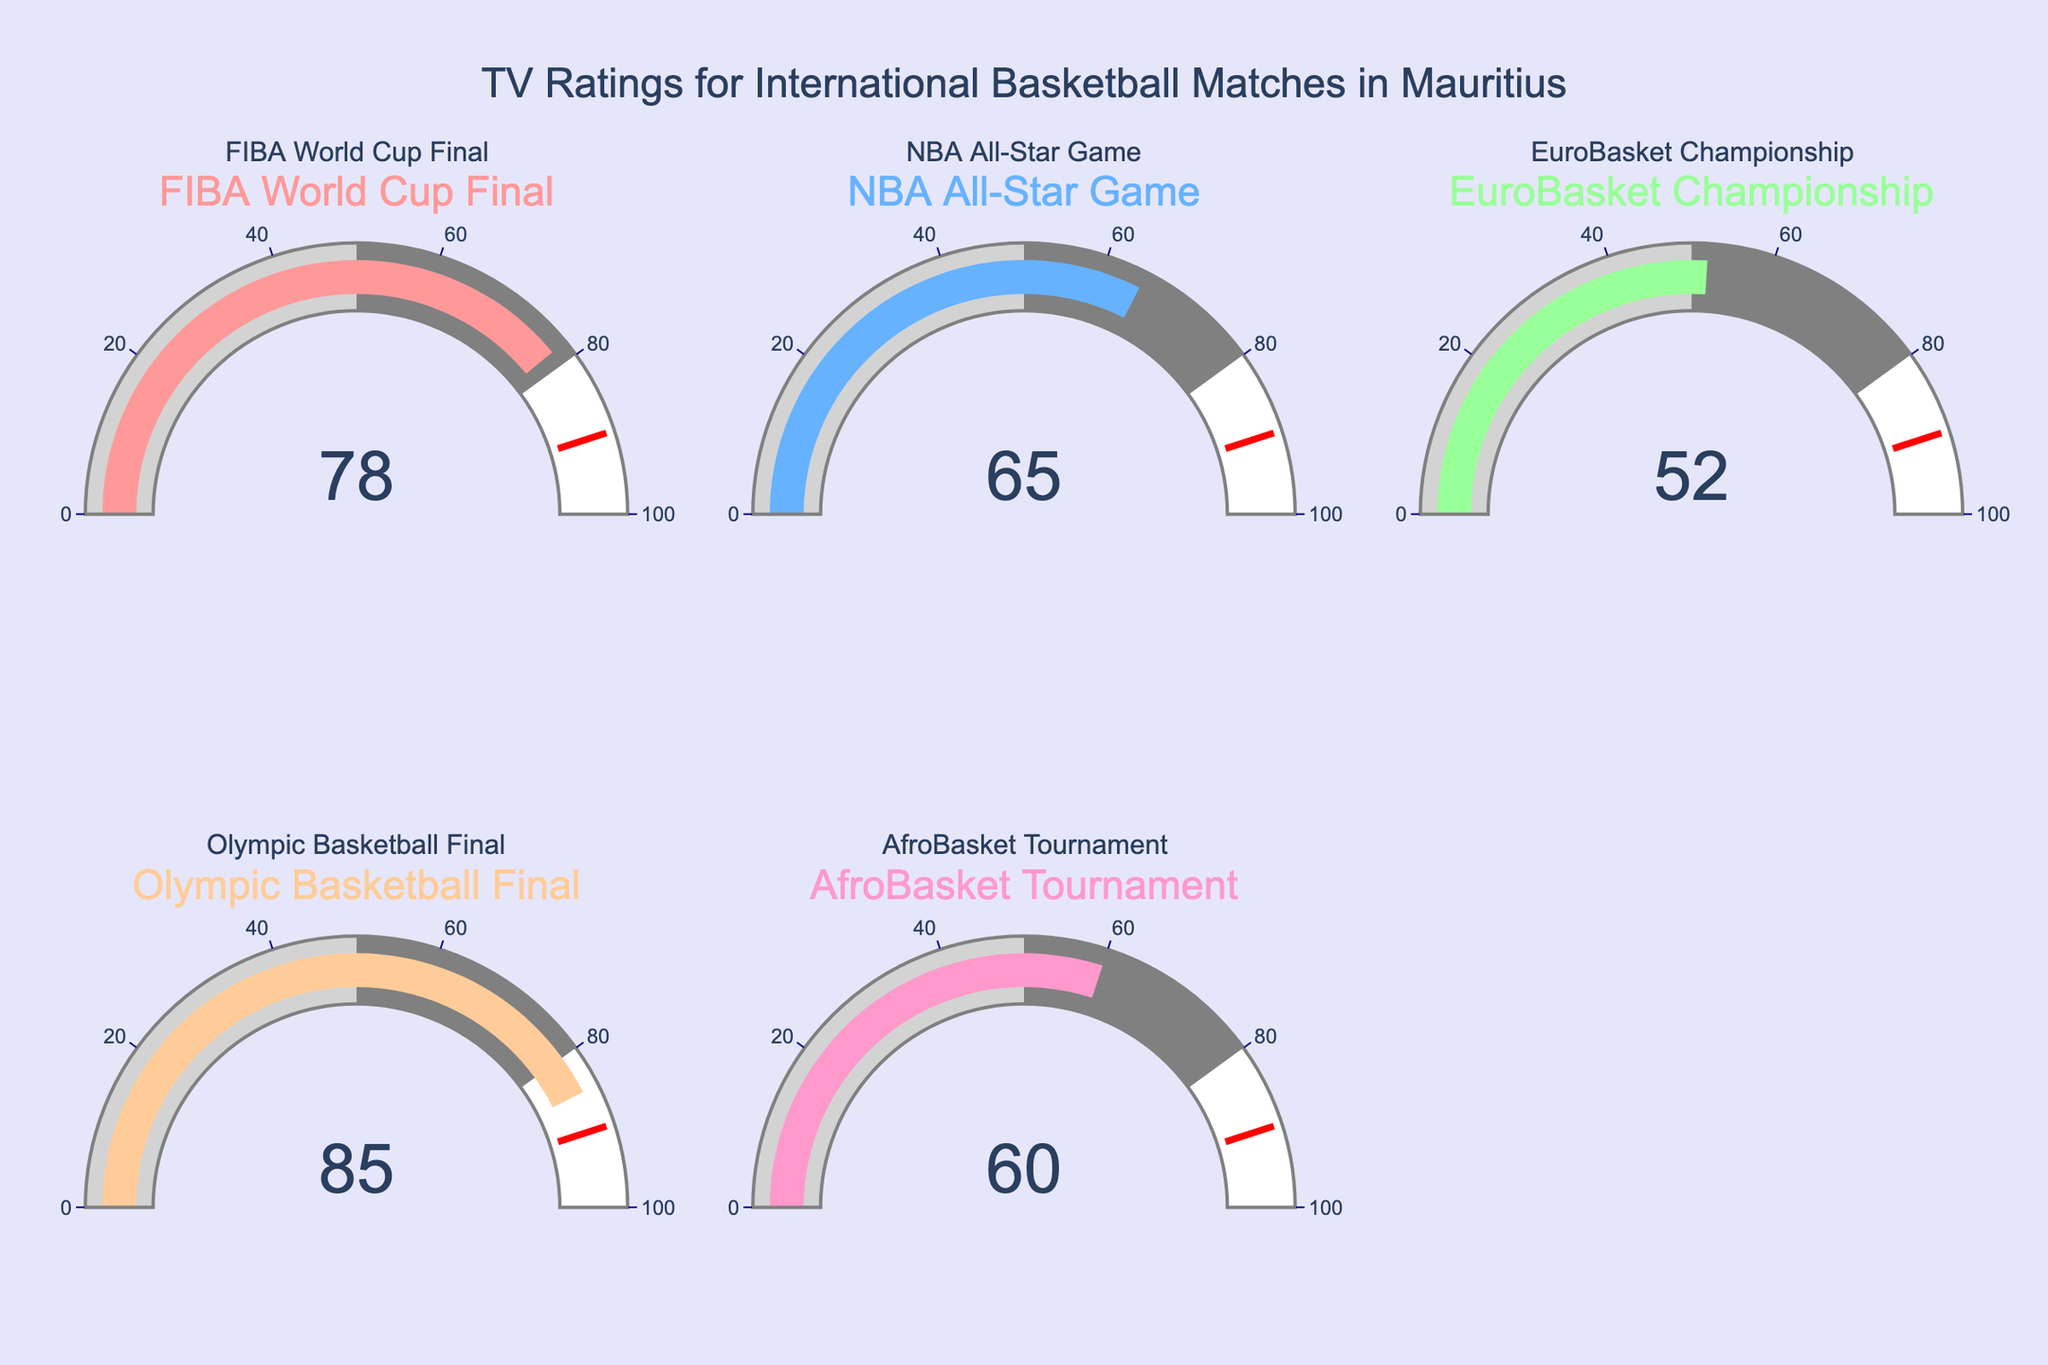How many events are listed in the figure? Count the gauges displayed in the subplot grid. There are 5 gauges, each representing a different event.
Answer: 5 Which event has the highest TV rating? Look at the gauge indicating the highest number. The Olympic Basketball Final has the highest TV rating of 85.
Answer: Olympic Basketball Final Compare the TV ratings of the FIBA World Cup Final and the NBA All-Star Game. Which one has a higher rating, and by how much? The FIBA World Cup Final has a rating of 78, and the NBA All-Star Game has a rating of 65. The difference is 78 - 65 = 13.
Answer: FIBA World Cup Final, 13 What is the average TV rating across all events? Sum the ratings of all events: 78 (FIBA) + 65 (NBA) + 52 (EuroBasket) + 85 (Olympic) + 60 (AfroBasket) = 340. Average = 340 / 5 = 68.
Answer: 68 Identify the event with the lowest TV rating. Look for the lowest value displayed in the gauges. The EuroBasket Championship has the lowest TV rating of 52.
Answer: EuroBasket Championship Is there any event with a TV rating above 80? If yes, which one? Check the ratings to identify any values above 80. The Olympic Basketball Final has a rating of 85.
Answer: Yes, Olympic Basketball Final What is the combined TV rating of the AfroBasket Tournament and the EuroBasket Championship? Add the ratings: AfroBasket (60) + EuroBasket (52) = 112.
Answer: 112 How many events have a TV rating below 70? Count the gauges with ratings below 70. AfroBasket (60), EuroBasket (52), and NBA All-Star Game (65) are below 70.
Answer: 3 Which event is within 10 points of the FIBA World Cup Final's rating? The FIBA World Cup Final has a rating of 78. Check for ratings between 68 and 88. The Olympic Basketball Final has a rating of 85, which is within this range (85 - 78 = 7).
Answer: Olympic Basketball Final 